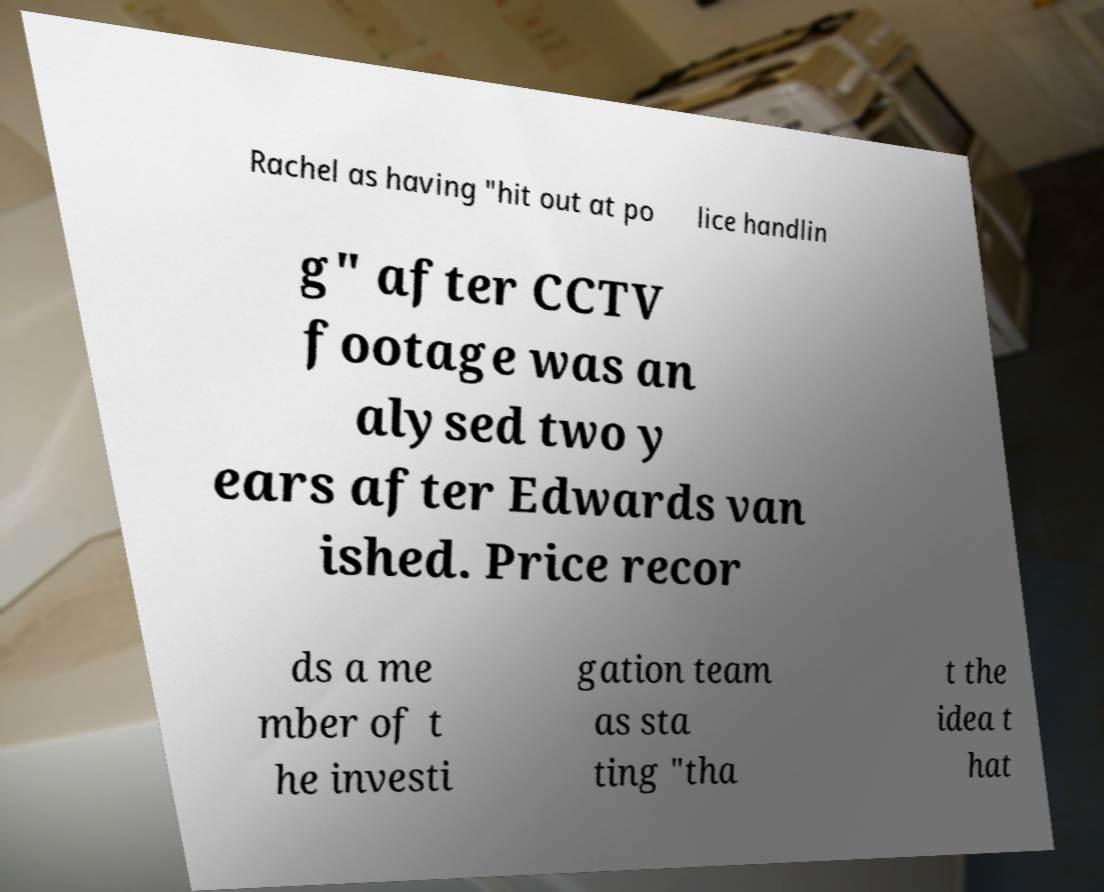Please read and relay the text visible in this image. What does it say? Rachel as having "hit out at po lice handlin g" after CCTV footage was an alysed two y ears after Edwards van ished. Price recor ds a me mber of t he investi gation team as sta ting "tha t the idea t hat 